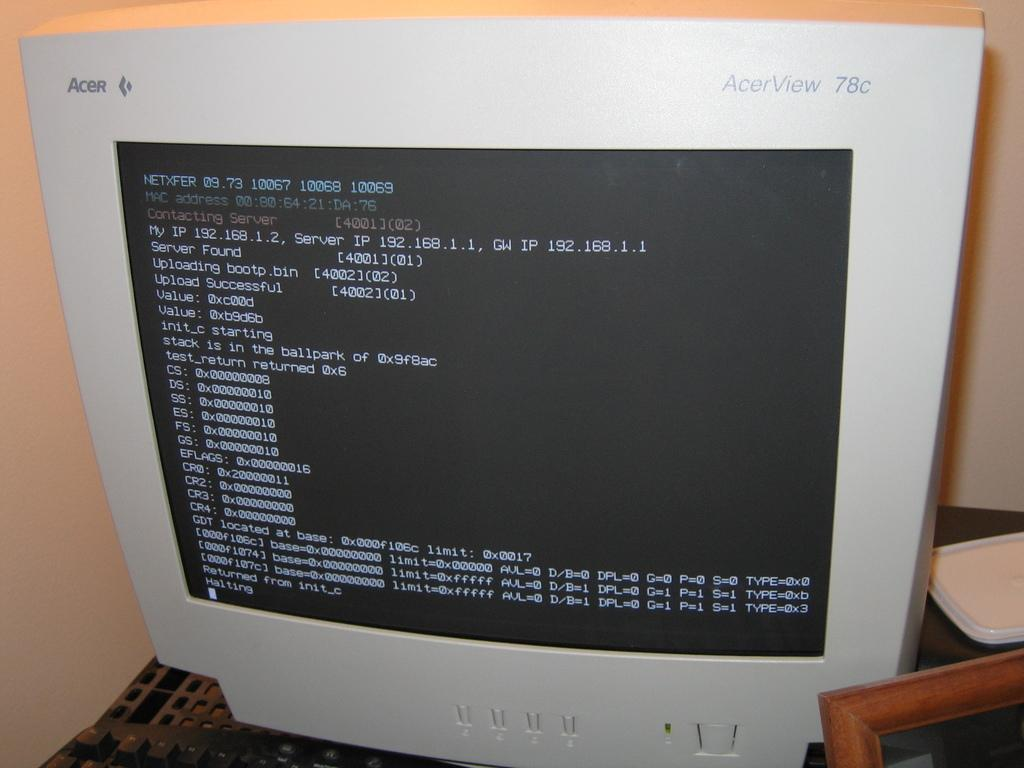Provide a one-sentence caption for the provided image. An AcerView 78C compute rmonitor displays several lines of code. 